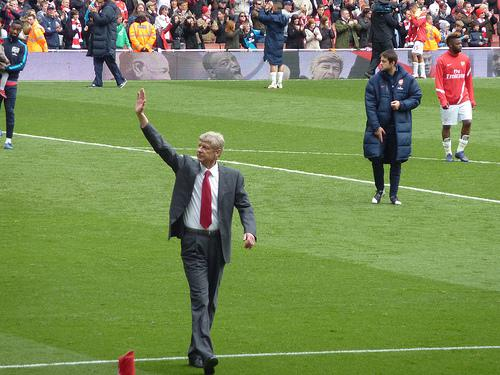Question: how many men on the field?
Choices:
A. 8.
B. 12.
C. 11.
D. 6.
Answer with the letter. Answer: A Question: why is the man's hand up?
Choices:
A. Saying stop.
B. Saluting.
C. Asking a question.
D. Waving.
Answer with the letter. Answer: D Question: what color is the coat?
Choices:
A. Blue.
B. Grey.
C. Black.
D. Brown.
Answer with the letter. Answer: A Question: what color is the man's tie?
Choices:
A. Blue.
B. Green.
C. Red.
D. Yellow.
Answer with the letter. Answer: C Question: who is wearing a red shirt?
Choices:
A. A woman.
B. A boy.
C. A man.
D. A girl.
Answer with the letter. Answer: C 